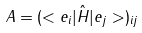Convert formula to latex. <formula><loc_0><loc_0><loc_500><loc_500>A = ( < e _ { i } | \hat { H } | e _ { j } > ) _ { i j }</formula> 